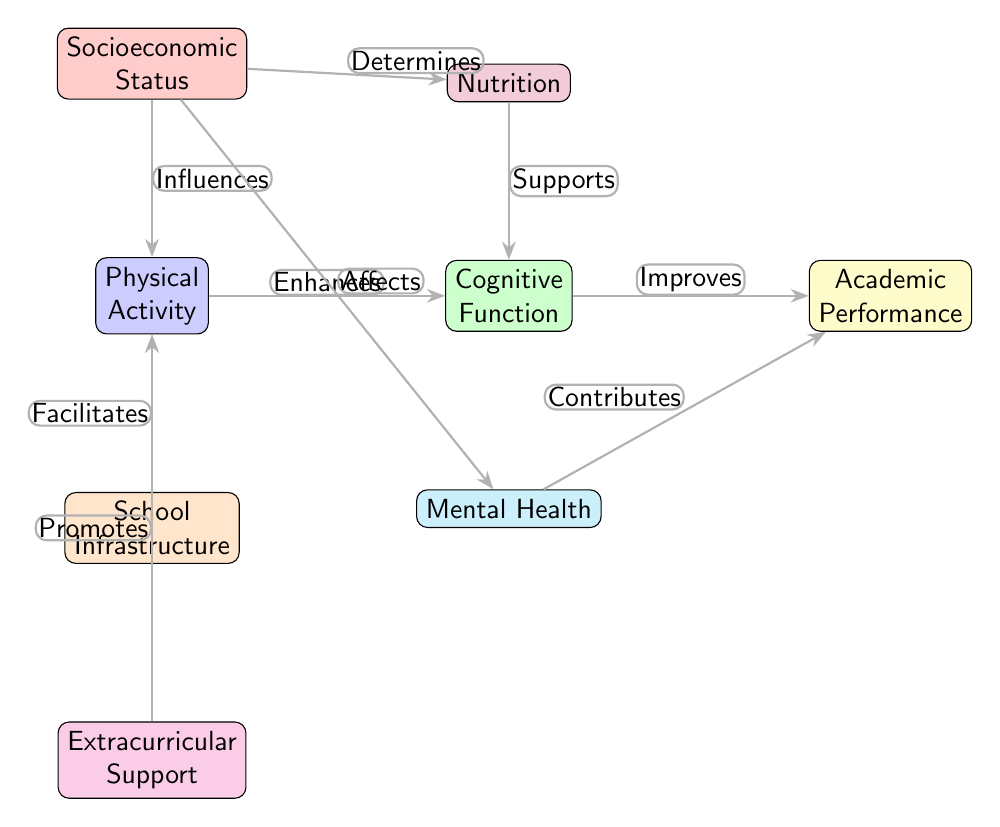What is the starting point of the diagram? The starting point is the "Physical Activity" node, which is the first node on the left side of the diagram. From there, connections lead to other related concepts.
Answer: Physical Activity How many nodes are present in the diagram? To find the total number of nodes, we count each distinct box or concept represented: Physical Activity, Cognitive Function, Academic Performance, Socioeconomic Status, School Infrastructure, Nutrition, Mental Health, and Extracurricular Support. This totals to 8 nodes.
Answer: 8 What does "Socioeconomic Status" influence in the diagram? The "Socioeconomic Status" node influences both "Physical Activity" and "Nutrition," indicating its role in these areas. Therefore, the answer is found by tracing the line from "Socioeconomic Status" to the two nodes it connects to.
Answer: Physical Activity and Nutrition Which two nodes are directly connected to "Mental Health"? The diagram shows that "Mental Health" is directly influenced by "Socioeconomic Status" and contributes to "Academic Performance." By examining the edges connected to "Mental Health," we can identify these relationships.
Answer: Socioeconomic Status and Academic Performance What role does "Nutrition" play in the diagram? "Nutrition" supports "Cognitive Function," which is indicated by the directed edge labeled "Supports." This means that adequate nutrition contributes positively to cognitive abilities, leading to better academic outcomes.
Answer: Supports Cognitive Function How does "Extracurricular Support" affect "Physical Activity"? "Extracurricular Support" promotes "Physical Activity,” which implies that providing children with extracurricular opportunities can enhance the levels of physical activity they engage in. This relationship indicates an encouraging influence on activity levels.
Answer: Promotes What is the relationship between "Cognitive Function" and "Academic Performance"? The diagram indicates that "Cognitive Function" improves "Academic Performance," suggesting that better cognitive skills translate directly into higher academic achievement, as denoted by the direction and label of the edge connecting these nodes.
Answer: Improves Which node has the most direct influences on "Academic Performance"? Upon examining the diagram, it is clear that both "Cognitive Function" and "Mental Health" have a direct influence on "Academic Performance," as indicated by the arrows pointing toward it. This means that these two factors are critical to academic success.
Answer: Cognitive Function and Mental Health 